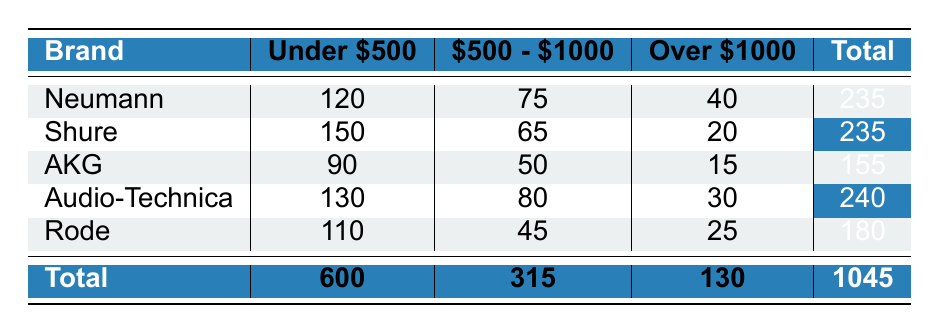What is the total number of units sold for Audio-Technica? The table shows that Audio-Technica has total units sold listed under the "Total" column, which is 240.
Answer: 240 Which brand sold the most units in the price range "Under $500"? By comparing the "Under $500" column, Shure has the highest units sold with 150, more than Neumann with 120 and Audio-Technica with 130.
Answer: Shure What is the total number of units sold across all brands in the price range "$500 - $1000"? To get the total units sold in this price range, we can sum the values: 75 (Neumann) + 65 (Shure) + 50 (AKG) + 80 (Audio-Technica) + 45 (Rode) = 315.
Answer: 315 Is the number of units sold for Neumann in the price range "Over $1000" higher than that for AKG in the same price range? Neumann sold 40 units while AKG sold 15 units in the "Over $1000" category. Since 40 is greater than 15, the statement is true.
Answer: Yes What is the average number of units sold for brands in the "Under $500" price range? There are five brands (Neumann, Shure, AKG, Audio-Technica, Rode) with units sold of 120, 150, 90, 130, and 110 respectively. Summing these gives 600, then dividing by 5 gives an average of 600/5 = 120.
Answer: 120 Which brand had the least total sales, and what is that total? By examining the "Total" column, AKG had the least units sold with a total of 155.
Answer: AKG, 155 How many more units did Shure sell in the "Under $500" range compared to Rode? Shure sold 150 units and Rode sold 110 units in the "Under $500" range. The difference is 150 - 110 = 40, meaning Shure sold 40 more units.
Answer: 40 What percentage of total sales does the "Over $1000" price range represent? The total units sold are 1045, and the units in the "Over $1000" range is 130. The percentage is (130 / 1045) * 100, which equals approximately 12.43%.
Answer: 12.43% Is the total number of units sold in the "Under $500" price range greater than 500? The total units sold in the "Under $500" category is 600, which is greater than 500, thus the statement is true.
Answer: Yes 